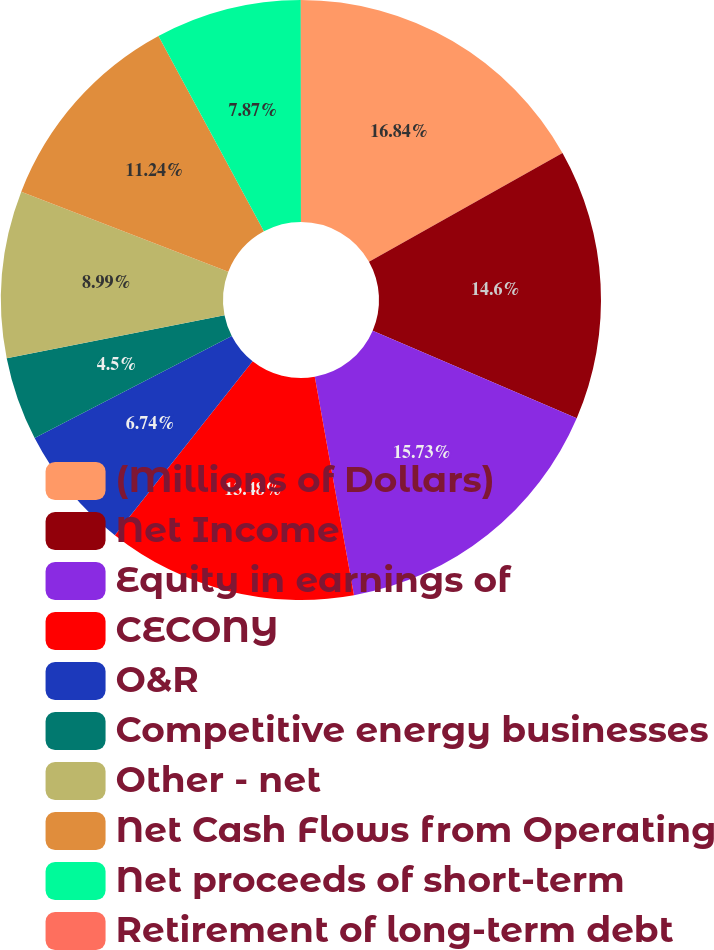Convert chart to OTSL. <chart><loc_0><loc_0><loc_500><loc_500><pie_chart><fcel>(Millions of Dollars)<fcel>Net Income<fcel>Equity in earnings of<fcel>CECONY<fcel>O&R<fcel>Competitive energy businesses<fcel>Other - net<fcel>Net Cash Flows from Operating<fcel>Net proceeds of short-term<fcel>Retirement of long-term debt<nl><fcel>16.85%<fcel>14.6%<fcel>15.73%<fcel>13.48%<fcel>6.74%<fcel>4.5%<fcel>8.99%<fcel>11.24%<fcel>7.87%<fcel>0.01%<nl></chart> 